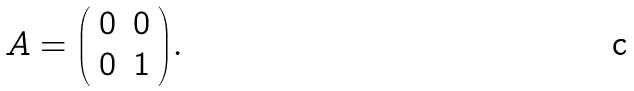<formula> <loc_0><loc_0><loc_500><loc_500>A = { \left ( \begin{array} { l l } { 0 } & { 0 } \\ { 0 } & { 1 } \end{array} \right ) } .</formula> 